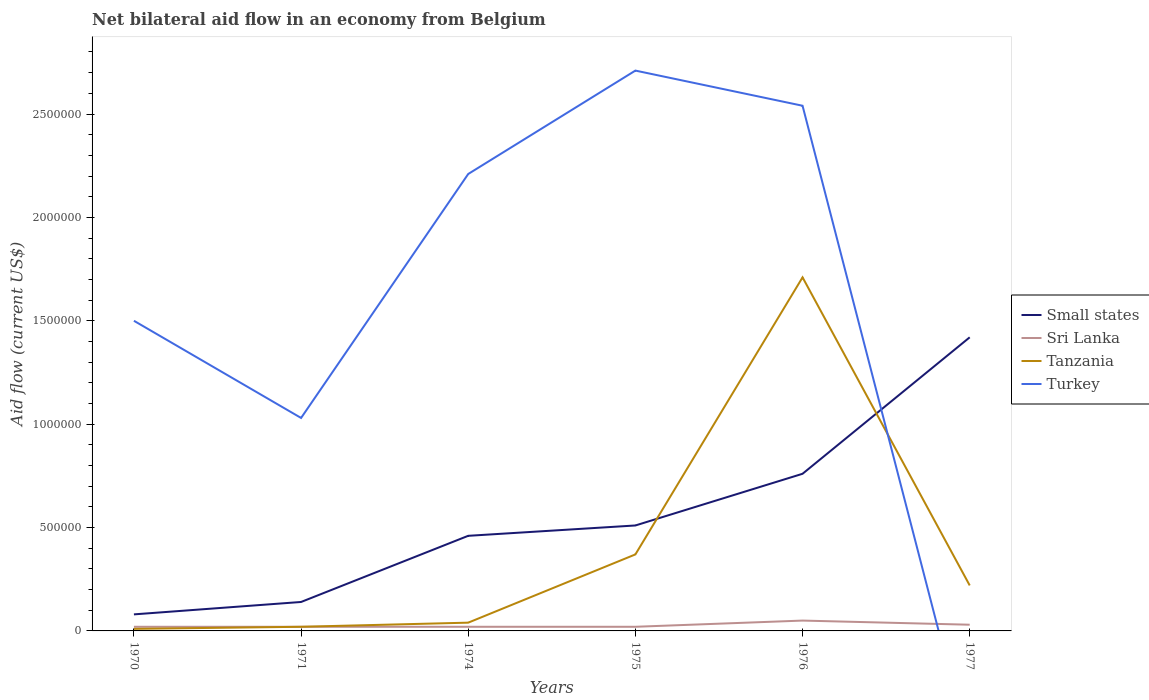What is the total net bilateral aid flow in Small states in the graph?
Keep it short and to the point. -3.20e+05. What is the difference between the highest and the second highest net bilateral aid flow in Small states?
Offer a very short reply. 1.34e+06. Is the net bilateral aid flow in Tanzania strictly greater than the net bilateral aid flow in Turkey over the years?
Make the answer very short. No. How many lines are there?
Keep it short and to the point. 4. Are the values on the major ticks of Y-axis written in scientific E-notation?
Offer a terse response. No. Does the graph contain any zero values?
Provide a short and direct response. Yes. Where does the legend appear in the graph?
Your answer should be very brief. Center right. What is the title of the graph?
Your answer should be compact. Net bilateral aid flow in an economy from Belgium. What is the label or title of the X-axis?
Keep it short and to the point. Years. What is the Aid flow (current US$) in Small states in 1970?
Provide a short and direct response. 8.00e+04. What is the Aid flow (current US$) of Sri Lanka in 1970?
Offer a terse response. 2.00e+04. What is the Aid flow (current US$) of Turkey in 1970?
Give a very brief answer. 1.50e+06. What is the Aid flow (current US$) of Sri Lanka in 1971?
Ensure brevity in your answer.  2.00e+04. What is the Aid flow (current US$) of Turkey in 1971?
Make the answer very short. 1.03e+06. What is the Aid flow (current US$) of Turkey in 1974?
Give a very brief answer. 2.21e+06. What is the Aid flow (current US$) in Small states in 1975?
Make the answer very short. 5.10e+05. What is the Aid flow (current US$) in Turkey in 1975?
Your response must be concise. 2.71e+06. What is the Aid flow (current US$) in Small states in 1976?
Provide a succinct answer. 7.60e+05. What is the Aid flow (current US$) of Tanzania in 1976?
Your answer should be very brief. 1.71e+06. What is the Aid flow (current US$) in Turkey in 1976?
Your answer should be compact. 2.54e+06. What is the Aid flow (current US$) of Small states in 1977?
Keep it short and to the point. 1.42e+06. Across all years, what is the maximum Aid flow (current US$) in Small states?
Offer a very short reply. 1.42e+06. Across all years, what is the maximum Aid flow (current US$) in Sri Lanka?
Keep it short and to the point. 5.00e+04. Across all years, what is the maximum Aid flow (current US$) in Tanzania?
Provide a short and direct response. 1.71e+06. Across all years, what is the maximum Aid flow (current US$) of Turkey?
Offer a terse response. 2.71e+06. Across all years, what is the minimum Aid flow (current US$) in Tanzania?
Offer a terse response. 10000. Across all years, what is the minimum Aid flow (current US$) in Turkey?
Your response must be concise. 0. What is the total Aid flow (current US$) in Small states in the graph?
Offer a very short reply. 3.37e+06. What is the total Aid flow (current US$) in Sri Lanka in the graph?
Your answer should be compact. 1.60e+05. What is the total Aid flow (current US$) in Tanzania in the graph?
Make the answer very short. 2.37e+06. What is the total Aid flow (current US$) in Turkey in the graph?
Your answer should be very brief. 9.99e+06. What is the difference between the Aid flow (current US$) in Tanzania in 1970 and that in 1971?
Provide a short and direct response. -10000. What is the difference between the Aid flow (current US$) of Small states in 1970 and that in 1974?
Ensure brevity in your answer.  -3.80e+05. What is the difference between the Aid flow (current US$) of Turkey in 1970 and that in 1974?
Provide a succinct answer. -7.10e+05. What is the difference between the Aid flow (current US$) in Small states in 1970 and that in 1975?
Provide a short and direct response. -4.30e+05. What is the difference between the Aid flow (current US$) of Sri Lanka in 1970 and that in 1975?
Make the answer very short. 0. What is the difference between the Aid flow (current US$) of Tanzania in 1970 and that in 1975?
Provide a succinct answer. -3.60e+05. What is the difference between the Aid flow (current US$) of Turkey in 1970 and that in 1975?
Offer a very short reply. -1.21e+06. What is the difference between the Aid flow (current US$) of Small states in 1970 and that in 1976?
Your answer should be very brief. -6.80e+05. What is the difference between the Aid flow (current US$) in Tanzania in 1970 and that in 1976?
Keep it short and to the point. -1.70e+06. What is the difference between the Aid flow (current US$) of Turkey in 1970 and that in 1976?
Provide a succinct answer. -1.04e+06. What is the difference between the Aid flow (current US$) in Small states in 1970 and that in 1977?
Give a very brief answer. -1.34e+06. What is the difference between the Aid flow (current US$) in Tanzania in 1970 and that in 1977?
Your answer should be very brief. -2.10e+05. What is the difference between the Aid flow (current US$) in Small states in 1971 and that in 1974?
Make the answer very short. -3.20e+05. What is the difference between the Aid flow (current US$) of Sri Lanka in 1971 and that in 1974?
Your answer should be very brief. 0. What is the difference between the Aid flow (current US$) of Tanzania in 1971 and that in 1974?
Your answer should be very brief. -2.00e+04. What is the difference between the Aid flow (current US$) of Turkey in 1971 and that in 1974?
Make the answer very short. -1.18e+06. What is the difference between the Aid flow (current US$) in Small states in 1971 and that in 1975?
Your answer should be very brief. -3.70e+05. What is the difference between the Aid flow (current US$) in Tanzania in 1971 and that in 1975?
Keep it short and to the point. -3.50e+05. What is the difference between the Aid flow (current US$) of Turkey in 1971 and that in 1975?
Give a very brief answer. -1.68e+06. What is the difference between the Aid flow (current US$) in Small states in 1971 and that in 1976?
Provide a short and direct response. -6.20e+05. What is the difference between the Aid flow (current US$) in Tanzania in 1971 and that in 1976?
Provide a succinct answer. -1.69e+06. What is the difference between the Aid flow (current US$) of Turkey in 1971 and that in 1976?
Ensure brevity in your answer.  -1.51e+06. What is the difference between the Aid flow (current US$) in Small states in 1971 and that in 1977?
Give a very brief answer. -1.28e+06. What is the difference between the Aid flow (current US$) of Sri Lanka in 1971 and that in 1977?
Keep it short and to the point. -10000. What is the difference between the Aid flow (current US$) in Tanzania in 1971 and that in 1977?
Make the answer very short. -2.00e+05. What is the difference between the Aid flow (current US$) in Small states in 1974 and that in 1975?
Your answer should be compact. -5.00e+04. What is the difference between the Aid flow (current US$) in Tanzania in 1974 and that in 1975?
Your response must be concise. -3.30e+05. What is the difference between the Aid flow (current US$) in Turkey in 1974 and that in 1975?
Your answer should be very brief. -5.00e+05. What is the difference between the Aid flow (current US$) in Sri Lanka in 1974 and that in 1976?
Your response must be concise. -3.00e+04. What is the difference between the Aid flow (current US$) in Tanzania in 1974 and that in 1976?
Provide a succinct answer. -1.67e+06. What is the difference between the Aid flow (current US$) of Turkey in 1974 and that in 1976?
Give a very brief answer. -3.30e+05. What is the difference between the Aid flow (current US$) in Small states in 1974 and that in 1977?
Provide a short and direct response. -9.60e+05. What is the difference between the Aid flow (current US$) of Sri Lanka in 1974 and that in 1977?
Make the answer very short. -10000. What is the difference between the Aid flow (current US$) of Small states in 1975 and that in 1976?
Your response must be concise. -2.50e+05. What is the difference between the Aid flow (current US$) of Tanzania in 1975 and that in 1976?
Provide a succinct answer. -1.34e+06. What is the difference between the Aid flow (current US$) of Small states in 1975 and that in 1977?
Keep it short and to the point. -9.10e+05. What is the difference between the Aid flow (current US$) in Tanzania in 1975 and that in 1977?
Your answer should be compact. 1.50e+05. What is the difference between the Aid flow (current US$) in Small states in 1976 and that in 1977?
Your response must be concise. -6.60e+05. What is the difference between the Aid flow (current US$) in Tanzania in 1976 and that in 1977?
Provide a succinct answer. 1.49e+06. What is the difference between the Aid flow (current US$) of Small states in 1970 and the Aid flow (current US$) of Sri Lanka in 1971?
Provide a short and direct response. 6.00e+04. What is the difference between the Aid flow (current US$) in Small states in 1970 and the Aid flow (current US$) in Tanzania in 1971?
Keep it short and to the point. 6.00e+04. What is the difference between the Aid flow (current US$) of Small states in 1970 and the Aid flow (current US$) of Turkey in 1971?
Keep it short and to the point. -9.50e+05. What is the difference between the Aid flow (current US$) in Sri Lanka in 1970 and the Aid flow (current US$) in Tanzania in 1971?
Offer a terse response. 0. What is the difference between the Aid flow (current US$) of Sri Lanka in 1970 and the Aid flow (current US$) of Turkey in 1971?
Provide a short and direct response. -1.01e+06. What is the difference between the Aid flow (current US$) in Tanzania in 1970 and the Aid flow (current US$) in Turkey in 1971?
Offer a very short reply. -1.02e+06. What is the difference between the Aid flow (current US$) of Small states in 1970 and the Aid flow (current US$) of Sri Lanka in 1974?
Provide a succinct answer. 6.00e+04. What is the difference between the Aid flow (current US$) in Small states in 1970 and the Aid flow (current US$) in Turkey in 1974?
Provide a succinct answer. -2.13e+06. What is the difference between the Aid flow (current US$) in Sri Lanka in 1970 and the Aid flow (current US$) in Turkey in 1974?
Provide a short and direct response. -2.19e+06. What is the difference between the Aid flow (current US$) of Tanzania in 1970 and the Aid flow (current US$) of Turkey in 1974?
Provide a succinct answer. -2.20e+06. What is the difference between the Aid flow (current US$) of Small states in 1970 and the Aid flow (current US$) of Sri Lanka in 1975?
Provide a short and direct response. 6.00e+04. What is the difference between the Aid flow (current US$) of Small states in 1970 and the Aid flow (current US$) of Tanzania in 1975?
Provide a short and direct response. -2.90e+05. What is the difference between the Aid flow (current US$) in Small states in 1970 and the Aid flow (current US$) in Turkey in 1975?
Your answer should be compact. -2.63e+06. What is the difference between the Aid flow (current US$) of Sri Lanka in 1970 and the Aid flow (current US$) of Tanzania in 1975?
Offer a very short reply. -3.50e+05. What is the difference between the Aid flow (current US$) in Sri Lanka in 1970 and the Aid flow (current US$) in Turkey in 1975?
Offer a very short reply. -2.69e+06. What is the difference between the Aid flow (current US$) in Tanzania in 1970 and the Aid flow (current US$) in Turkey in 1975?
Give a very brief answer. -2.70e+06. What is the difference between the Aid flow (current US$) in Small states in 1970 and the Aid flow (current US$) in Tanzania in 1976?
Your answer should be compact. -1.63e+06. What is the difference between the Aid flow (current US$) of Small states in 1970 and the Aid flow (current US$) of Turkey in 1976?
Offer a very short reply. -2.46e+06. What is the difference between the Aid flow (current US$) in Sri Lanka in 1970 and the Aid flow (current US$) in Tanzania in 1976?
Your answer should be very brief. -1.69e+06. What is the difference between the Aid flow (current US$) in Sri Lanka in 1970 and the Aid flow (current US$) in Turkey in 1976?
Your response must be concise. -2.52e+06. What is the difference between the Aid flow (current US$) in Tanzania in 1970 and the Aid flow (current US$) in Turkey in 1976?
Keep it short and to the point. -2.53e+06. What is the difference between the Aid flow (current US$) in Small states in 1971 and the Aid flow (current US$) in Sri Lanka in 1974?
Give a very brief answer. 1.20e+05. What is the difference between the Aid flow (current US$) of Small states in 1971 and the Aid flow (current US$) of Turkey in 1974?
Offer a very short reply. -2.07e+06. What is the difference between the Aid flow (current US$) in Sri Lanka in 1971 and the Aid flow (current US$) in Turkey in 1974?
Offer a very short reply. -2.19e+06. What is the difference between the Aid flow (current US$) in Tanzania in 1971 and the Aid flow (current US$) in Turkey in 1974?
Provide a short and direct response. -2.19e+06. What is the difference between the Aid flow (current US$) of Small states in 1971 and the Aid flow (current US$) of Sri Lanka in 1975?
Keep it short and to the point. 1.20e+05. What is the difference between the Aid flow (current US$) in Small states in 1971 and the Aid flow (current US$) in Tanzania in 1975?
Keep it short and to the point. -2.30e+05. What is the difference between the Aid flow (current US$) in Small states in 1971 and the Aid flow (current US$) in Turkey in 1975?
Keep it short and to the point. -2.57e+06. What is the difference between the Aid flow (current US$) of Sri Lanka in 1971 and the Aid flow (current US$) of Tanzania in 1975?
Offer a very short reply. -3.50e+05. What is the difference between the Aid flow (current US$) of Sri Lanka in 1971 and the Aid flow (current US$) of Turkey in 1975?
Your answer should be compact. -2.69e+06. What is the difference between the Aid flow (current US$) in Tanzania in 1971 and the Aid flow (current US$) in Turkey in 1975?
Your answer should be very brief. -2.69e+06. What is the difference between the Aid flow (current US$) of Small states in 1971 and the Aid flow (current US$) of Sri Lanka in 1976?
Your response must be concise. 9.00e+04. What is the difference between the Aid flow (current US$) in Small states in 1971 and the Aid flow (current US$) in Tanzania in 1976?
Provide a succinct answer. -1.57e+06. What is the difference between the Aid flow (current US$) of Small states in 1971 and the Aid flow (current US$) of Turkey in 1976?
Your answer should be very brief. -2.40e+06. What is the difference between the Aid flow (current US$) in Sri Lanka in 1971 and the Aid flow (current US$) in Tanzania in 1976?
Offer a very short reply. -1.69e+06. What is the difference between the Aid flow (current US$) in Sri Lanka in 1971 and the Aid flow (current US$) in Turkey in 1976?
Make the answer very short. -2.52e+06. What is the difference between the Aid flow (current US$) in Tanzania in 1971 and the Aid flow (current US$) in Turkey in 1976?
Your answer should be compact. -2.52e+06. What is the difference between the Aid flow (current US$) in Sri Lanka in 1971 and the Aid flow (current US$) in Tanzania in 1977?
Provide a short and direct response. -2.00e+05. What is the difference between the Aid flow (current US$) in Small states in 1974 and the Aid flow (current US$) in Turkey in 1975?
Offer a terse response. -2.25e+06. What is the difference between the Aid flow (current US$) in Sri Lanka in 1974 and the Aid flow (current US$) in Tanzania in 1975?
Your response must be concise. -3.50e+05. What is the difference between the Aid flow (current US$) in Sri Lanka in 1974 and the Aid flow (current US$) in Turkey in 1975?
Your response must be concise. -2.69e+06. What is the difference between the Aid flow (current US$) in Tanzania in 1974 and the Aid flow (current US$) in Turkey in 1975?
Your response must be concise. -2.67e+06. What is the difference between the Aid flow (current US$) in Small states in 1974 and the Aid flow (current US$) in Sri Lanka in 1976?
Offer a very short reply. 4.10e+05. What is the difference between the Aid flow (current US$) of Small states in 1974 and the Aid flow (current US$) of Tanzania in 1976?
Offer a terse response. -1.25e+06. What is the difference between the Aid flow (current US$) of Small states in 1974 and the Aid flow (current US$) of Turkey in 1976?
Provide a short and direct response. -2.08e+06. What is the difference between the Aid flow (current US$) in Sri Lanka in 1974 and the Aid flow (current US$) in Tanzania in 1976?
Keep it short and to the point. -1.69e+06. What is the difference between the Aid flow (current US$) of Sri Lanka in 1974 and the Aid flow (current US$) of Turkey in 1976?
Make the answer very short. -2.52e+06. What is the difference between the Aid flow (current US$) of Tanzania in 1974 and the Aid flow (current US$) of Turkey in 1976?
Make the answer very short. -2.50e+06. What is the difference between the Aid flow (current US$) of Small states in 1974 and the Aid flow (current US$) of Sri Lanka in 1977?
Your answer should be very brief. 4.30e+05. What is the difference between the Aid flow (current US$) of Small states in 1975 and the Aid flow (current US$) of Sri Lanka in 1976?
Your answer should be very brief. 4.60e+05. What is the difference between the Aid flow (current US$) of Small states in 1975 and the Aid flow (current US$) of Tanzania in 1976?
Offer a very short reply. -1.20e+06. What is the difference between the Aid flow (current US$) of Small states in 1975 and the Aid flow (current US$) of Turkey in 1976?
Make the answer very short. -2.03e+06. What is the difference between the Aid flow (current US$) in Sri Lanka in 1975 and the Aid flow (current US$) in Tanzania in 1976?
Your answer should be very brief. -1.69e+06. What is the difference between the Aid flow (current US$) of Sri Lanka in 1975 and the Aid flow (current US$) of Turkey in 1976?
Your response must be concise. -2.52e+06. What is the difference between the Aid flow (current US$) of Tanzania in 1975 and the Aid flow (current US$) of Turkey in 1976?
Make the answer very short. -2.17e+06. What is the difference between the Aid flow (current US$) in Small states in 1975 and the Aid flow (current US$) in Tanzania in 1977?
Ensure brevity in your answer.  2.90e+05. What is the difference between the Aid flow (current US$) in Sri Lanka in 1975 and the Aid flow (current US$) in Tanzania in 1977?
Keep it short and to the point. -2.00e+05. What is the difference between the Aid flow (current US$) in Small states in 1976 and the Aid flow (current US$) in Sri Lanka in 1977?
Provide a succinct answer. 7.30e+05. What is the difference between the Aid flow (current US$) of Small states in 1976 and the Aid flow (current US$) of Tanzania in 1977?
Offer a very short reply. 5.40e+05. What is the difference between the Aid flow (current US$) of Sri Lanka in 1976 and the Aid flow (current US$) of Tanzania in 1977?
Your answer should be very brief. -1.70e+05. What is the average Aid flow (current US$) in Small states per year?
Your answer should be very brief. 5.62e+05. What is the average Aid flow (current US$) in Sri Lanka per year?
Offer a very short reply. 2.67e+04. What is the average Aid flow (current US$) of Tanzania per year?
Your answer should be compact. 3.95e+05. What is the average Aid flow (current US$) in Turkey per year?
Ensure brevity in your answer.  1.66e+06. In the year 1970, what is the difference between the Aid flow (current US$) of Small states and Aid flow (current US$) of Sri Lanka?
Offer a very short reply. 6.00e+04. In the year 1970, what is the difference between the Aid flow (current US$) of Small states and Aid flow (current US$) of Turkey?
Make the answer very short. -1.42e+06. In the year 1970, what is the difference between the Aid flow (current US$) in Sri Lanka and Aid flow (current US$) in Tanzania?
Your answer should be very brief. 10000. In the year 1970, what is the difference between the Aid flow (current US$) of Sri Lanka and Aid flow (current US$) of Turkey?
Give a very brief answer. -1.48e+06. In the year 1970, what is the difference between the Aid flow (current US$) of Tanzania and Aid flow (current US$) of Turkey?
Keep it short and to the point. -1.49e+06. In the year 1971, what is the difference between the Aid flow (current US$) of Small states and Aid flow (current US$) of Sri Lanka?
Your response must be concise. 1.20e+05. In the year 1971, what is the difference between the Aid flow (current US$) in Small states and Aid flow (current US$) in Tanzania?
Make the answer very short. 1.20e+05. In the year 1971, what is the difference between the Aid flow (current US$) of Small states and Aid flow (current US$) of Turkey?
Offer a terse response. -8.90e+05. In the year 1971, what is the difference between the Aid flow (current US$) of Sri Lanka and Aid flow (current US$) of Turkey?
Your answer should be very brief. -1.01e+06. In the year 1971, what is the difference between the Aid flow (current US$) of Tanzania and Aid flow (current US$) of Turkey?
Ensure brevity in your answer.  -1.01e+06. In the year 1974, what is the difference between the Aid flow (current US$) in Small states and Aid flow (current US$) in Tanzania?
Make the answer very short. 4.20e+05. In the year 1974, what is the difference between the Aid flow (current US$) of Small states and Aid flow (current US$) of Turkey?
Your answer should be compact. -1.75e+06. In the year 1974, what is the difference between the Aid flow (current US$) of Sri Lanka and Aid flow (current US$) of Turkey?
Give a very brief answer. -2.19e+06. In the year 1974, what is the difference between the Aid flow (current US$) of Tanzania and Aid flow (current US$) of Turkey?
Provide a short and direct response. -2.17e+06. In the year 1975, what is the difference between the Aid flow (current US$) of Small states and Aid flow (current US$) of Sri Lanka?
Keep it short and to the point. 4.90e+05. In the year 1975, what is the difference between the Aid flow (current US$) of Small states and Aid flow (current US$) of Turkey?
Your answer should be very brief. -2.20e+06. In the year 1975, what is the difference between the Aid flow (current US$) of Sri Lanka and Aid flow (current US$) of Tanzania?
Your answer should be compact. -3.50e+05. In the year 1975, what is the difference between the Aid flow (current US$) of Sri Lanka and Aid flow (current US$) of Turkey?
Give a very brief answer. -2.69e+06. In the year 1975, what is the difference between the Aid flow (current US$) in Tanzania and Aid flow (current US$) in Turkey?
Ensure brevity in your answer.  -2.34e+06. In the year 1976, what is the difference between the Aid flow (current US$) in Small states and Aid flow (current US$) in Sri Lanka?
Your answer should be very brief. 7.10e+05. In the year 1976, what is the difference between the Aid flow (current US$) in Small states and Aid flow (current US$) in Tanzania?
Your answer should be very brief. -9.50e+05. In the year 1976, what is the difference between the Aid flow (current US$) of Small states and Aid flow (current US$) of Turkey?
Your answer should be very brief. -1.78e+06. In the year 1976, what is the difference between the Aid flow (current US$) of Sri Lanka and Aid flow (current US$) of Tanzania?
Provide a succinct answer. -1.66e+06. In the year 1976, what is the difference between the Aid flow (current US$) in Sri Lanka and Aid flow (current US$) in Turkey?
Make the answer very short. -2.49e+06. In the year 1976, what is the difference between the Aid flow (current US$) in Tanzania and Aid flow (current US$) in Turkey?
Offer a terse response. -8.30e+05. In the year 1977, what is the difference between the Aid flow (current US$) of Small states and Aid flow (current US$) of Sri Lanka?
Your response must be concise. 1.39e+06. In the year 1977, what is the difference between the Aid flow (current US$) in Small states and Aid flow (current US$) in Tanzania?
Your answer should be very brief. 1.20e+06. In the year 1977, what is the difference between the Aid flow (current US$) of Sri Lanka and Aid flow (current US$) of Tanzania?
Give a very brief answer. -1.90e+05. What is the ratio of the Aid flow (current US$) in Sri Lanka in 1970 to that in 1971?
Provide a succinct answer. 1. What is the ratio of the Aid flow (current US$) in Tanzania in 1970 to that in 1971?
Ensure brevity in your answer.  0.5. What is the ratio of the Aid flow (current US$) of Turkey in 1970 to that in 1971?
Give a very brief answer. 1.46. What is the ratio of the Aid flow (current US$) of Small states in 1970 to that in 1974?
Offer a very short reply. 0.17. What is the ratio of the Aid flow (current US$) in Sri Lanka in 1970 to that in 1974?
Keep it short and to the point. 1. What is the ratio of the Aid flow (current US$) of Tanzania in 1970 to that in 1974?
Ensure brevity in your answer.  0.25. What is the ratio of the Aid flow (current US$) in Turkey in 1970 to that in 1974?
Provide a succinct answer. 0.68. What is the ratio of the Aid flow (current US$) in Small states in 1970 to that in 1975?
Your answer should be very brief. 0.16. What is the ratio of the Aid flow (current US$) in Tanzania in 1970 to that in 1975?
Your answer should be very brief. 0.03. What is the ratio of the Aid flow (current US$) in Turkey in 1970 to that in 1975?
Offer a terse response. 0.55. What is the ratio of the Aid flow (current US$) in Small states in 1970 to that in 1976?
Your answer should be compact. 0.11. What is the ratio of the Aid flow (current US$) in Sri Lanka in 1970 to that in 1976?
Offer a terse response. 0.4. What is the ratio of the Aid flow (current US$) of Tanzania in 1970 to that in 1976?
Give a very brief answer. 0.01. What is the ratio of the Aid flow (current US$) in Turkey in 1970 to that in 1976?
Your answer should be very brief. 0.59. What is the ratio of the Aid flow (current US$) of Small states in 1970 to that in 1977?
Ensure brevity in your answer.  0.06. What is the ratio of the Aid flow (current US$) of Tanzania in 1970 to that in 1977?
Offer a terse response. 0.05. What is the ratio of the Aid flow (current US$) in Small states in 1971 to that in 1974?
Offer a terse response. 0.3. What is the ratio of the Aid flow (current US$) of Sri Lanka in 1971 to that in 1974?
Your answer should be compact. 1. What is the ratio of the Aid flow (current US$) in Tanzania in 1971 to that in 1974?
Provide a succinct answer. 0.5. What is the ratio of the Aid flow (current US$) of Turkey in 1971 to that in 1974?
Provide a short and direct response. 0.47. What is the ratio of the Aid flow (current US$) of Small states in 1971 to that in 1975?
Offer a very short reply. 0.27. What is the ratio of the Aid flow (current US$) in Sri Lanka in 1971 to that in 1975?
Give a very brief answer. 1. What is the ratio of the Aid flow (current US$) of Tanzania in 1971 to that in 1975?
Make the answer very short. 0.05. What is the ratio of the Aid flow (current US$) of Turkey in 1971 to that in 1975?
Your answer should be very brief. 0.38. What is the ratio of the Aid flow (current US$) in Small states in 1971 to that in 1976?
Your answer should be compact. 0.18. What is the ratio of the Aid flow (current US$) of Sri Lanka in 1971 to that in 1976?
Provide a succinct answer. 0.4. What is the ratio of the Aid flow (current US$) in Tanzania in 1971 to that in 1976?
Your response must be concise. 0.01. What is the ratio of the Aid flow (current US$) of Turkey in 1971 to that in 1976?
Provide a succinct answer. 0.41. What is the ratio of the Aid flow (current US$) of Small states in 1971 to that in 1977?
Your answer should be very brief. 0.1. What is the ratio of the Aid flow (current US$) in Tanzania in 1971 to that in 1977?
Your answer should be very brief. 0.09. What is the ratio of the Aid flow (current US$) in Small states in 1974 to that in 1975?
Give a very brief answer. 0.9. What is the ratio of the Aid flow (current US$) of Sri Lanka in 1974 to that in 1975?
Offer a very short reply. 1. What is the ratio of the Aid flow (current US$) in Tanzania in 1974 to that in 1975?
Offer a terse response. 0.11. What is the ratio of the Aid flow (current US$) of Turkey in 1974 to that in 1975?
Offer a very short reply. 0.82. What is the ratio of the Aid flow (current US$) of Small states in 1974 to that in 1976?
Make the answer very short. 0.61. What is the ratio of the Aid flow (current US$) of Tanzania in 1974 to that in 1976?
Offer a terse response. 0.02. What is the ratio of the Aid flow (current US$) in Turkey in 1974 to that in 1976?
Ensure brevity in your answer.  0.87. What is the ratio of the Aid flow (current US$) in Small states in 1974 to that in 1977?
Ensure brevity in your answer.  0.32. What is the ratio of the Aid flow (current US$) in Sri Lanka in 1974 to that in 1977?
Your response must be concise. 0.67. What is the ratio of the Aid flow (current US$) in Tanzania in 1974 to that in 1977?
Provide a succinct answer. 0.18. What is the ratio of the Aid flow (current US$) in Small states in 1975 to that in 1976?
Your response must be concise. 0.67. What is the ratio of the Aid flow (current US$) in Tanzania in 1975 to that in 1976?
Your answer should be very brief. 0.22. What is the ratio of the Aid flow (current US$) of Turkey in 1975 to that in 1976?
Ensure brevity in your answer.  1.07. What is the ratio of the Aid flow (current US$) in Small states in 1975 to that in 1977?
Make the answer very short. 0.36. What is the ratio of the Aid flow (current US$) of Sri Lanka in 1975 to that in 1977?
Offer a terse response. 0.67. What is the ratio of the Aid flow (current US$) of Tanzania in 1975 to that in 1977?
Offer a very short reply. 1.68. What is the ratio of the Aid flow (current US$) of Small states in 1976 to that in 1977?
Make the answer very short. 0.54. What is the ratio of the Aid flow (current US$) in Sri Lanka in 1976 to that in 1977?
Give a very brief answer. 1.67. What is the ratio of the Aid flow (current US$) of Tanzania in 1976 to that in 1977?
Give a very brief answer. 7.77. What is the difference between the highest and the second highest Aid flow (current US$) of Small states?
Your response must be concise. 6.60e+05. What is the difference between the highest and the second highest Aid flow (current US$) in Tanzania?
Your answer should be compact. 1.34e+06. What is the difference between the highest and the lowest Aid flow (current US$) in Small states?
Your answer should be compact. 1.34e+06. What is the difference between the highest and the lowest Aid flow (current US$) in Tanzania?
Provide a succinct answer. 1.70e+06. What is the difference between the highest and the lowest Aid flow (current US$) of Turkey?
Offer a very short reply. 2.71e+06. 